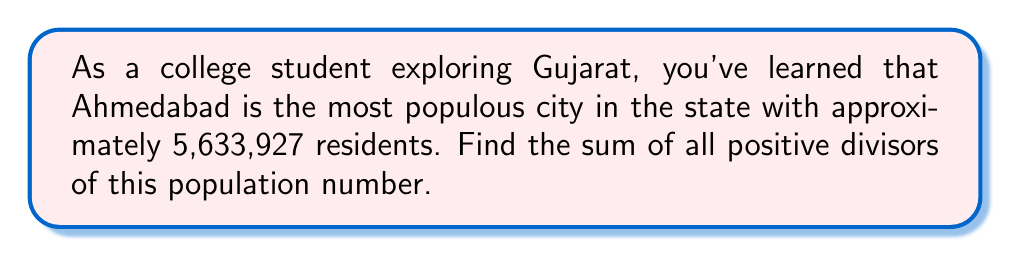Solve this math problem. Let's approach this step-by-step:

1) First, we need to factor the number 5,633,927:
   $5,633,927 = 3^3 \times 7 \times 89,427$

2) 89,427 can be further factored:
   $89,427 = 3 \times 29,809$

3) So, the complete factorization is:
   $5,633,927 = 3^4 \times 7 \times 29,809$

4) To find the sum of divisors, we can use the divisor function formula:

   For a number $N = p_1^{a_1} \times p_2^{a_2} \times ... \times p_k^{a_k}$, 
   the sum of its divisors is given by:

   $\sigma(N) = \prod_{i=1}^k \frac{p_i^{a_i+1}-1}{p_i-1}$

5) Applying this to our factorization:

   $\sigma(5,633,927) = \frac{3^5-1}{3-1} \times \frac{7^2-1}{7-1} \times \frac{29,809^2-1}{29,809-1}$

6) Let's calculate each part:

   $\frac{3^5-1}{3-1} = \frac{243-1}{2} = 121$

   $\frac{7^2-1}{7-1} = \frac{49-1}{6} = 8$

   $\frac{29,809^2-1}{29,809-1} = 29,810$

7) Multiplying these together:

   $121 \times 8 \times 29,810 = 28,845,680$
Answer: The sum of all positive divisors of 5,633,927 is 28,845,680. 